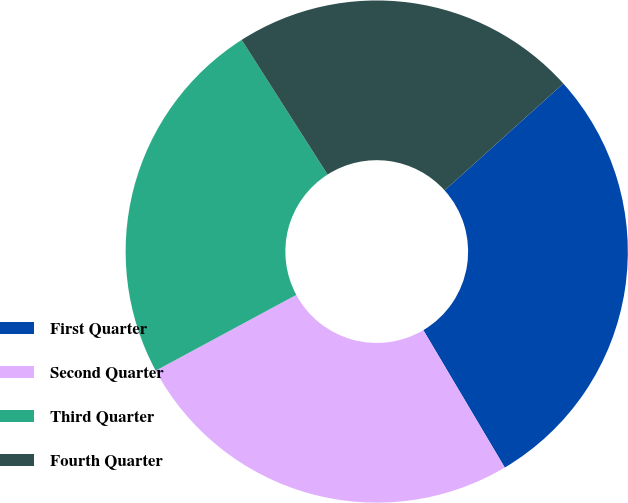Convert chart. <chart><loc_0><loc_0><loc_500><loc_500><pie_chart><fcel>First Quarter<fcel>Second Quarter<fcel>Third Quarter<fcel>Fourth Quarter<nl><fcel>28.15%<fcel>25.65%<fcel>23.83%<fcel>22.37%<nl></chart> 